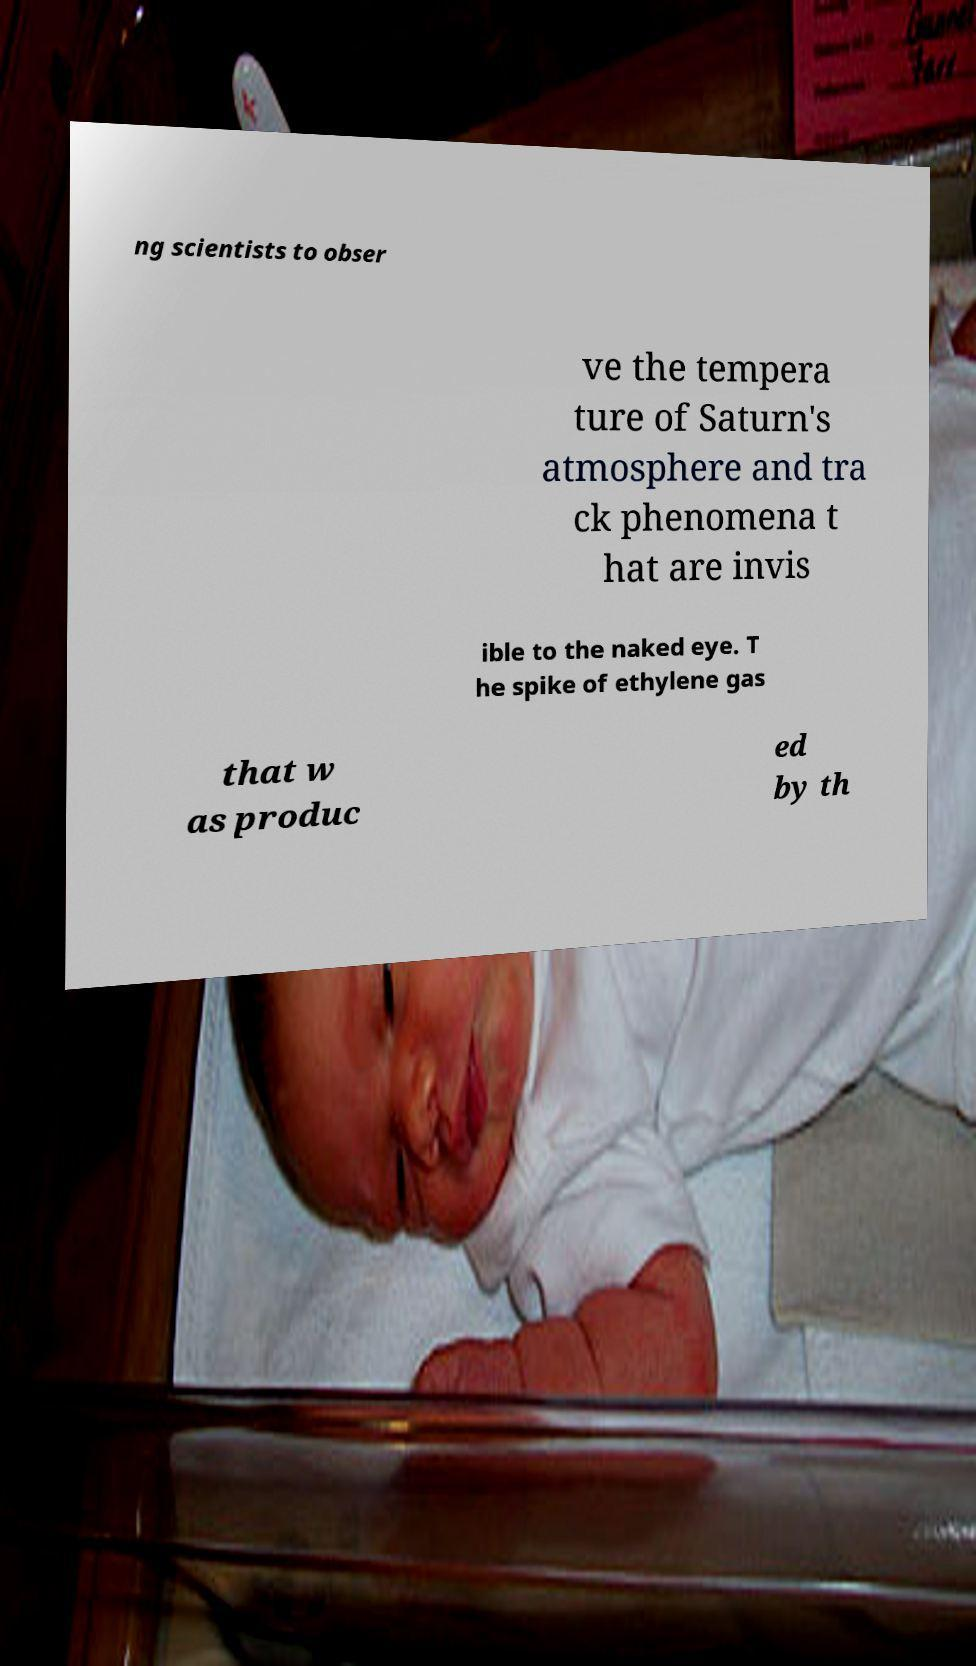Can you accurately transcribe the text from the provided image for me? ng scientists to obser ve the tempera ture of Saturn's atmosphere and tra ck phenomena t hat are invis ible to the naked eye. T he spike of ethylene gas that w as produc ed by th 